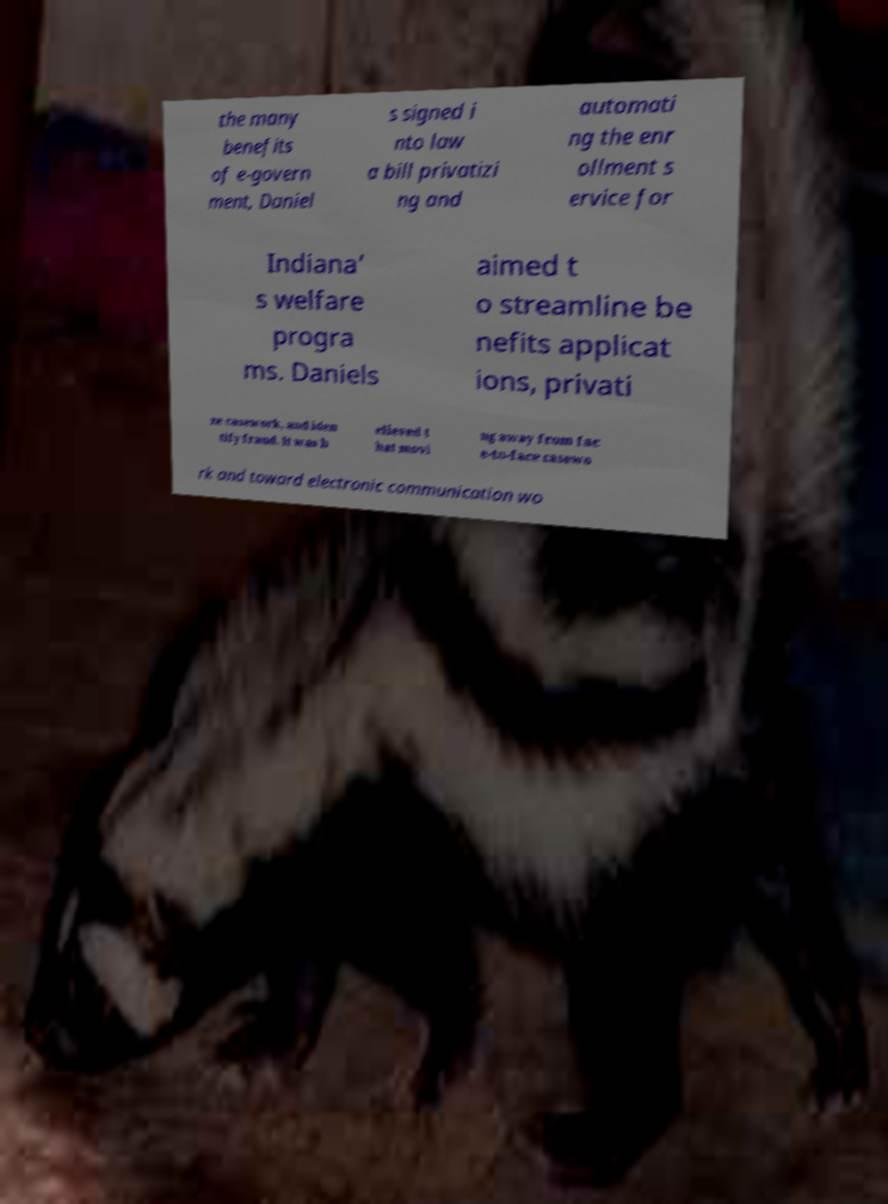There's text embedded in this image that I need extracted. Can you transcribe it verbatim? the many benefits of e-govern ment, Daniel s signed i nto law a bill privatizi ng and automati ng the enr ollment s ervice for Indiana’ s welfare progra ms. Daniels aimed t o streamline be nefits applicat ions, privati ze casework, and iden tify fraud. It was b elieved t hat movi ng away from fac e-to-face casewo rk and toward electronic communication wo 